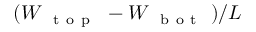Convert formula to latex. <formula><loc_0><loc_0><loc_500><loc_500>( W _ { { t o p } } - W _ { { b o t } } ) / L</formula> 